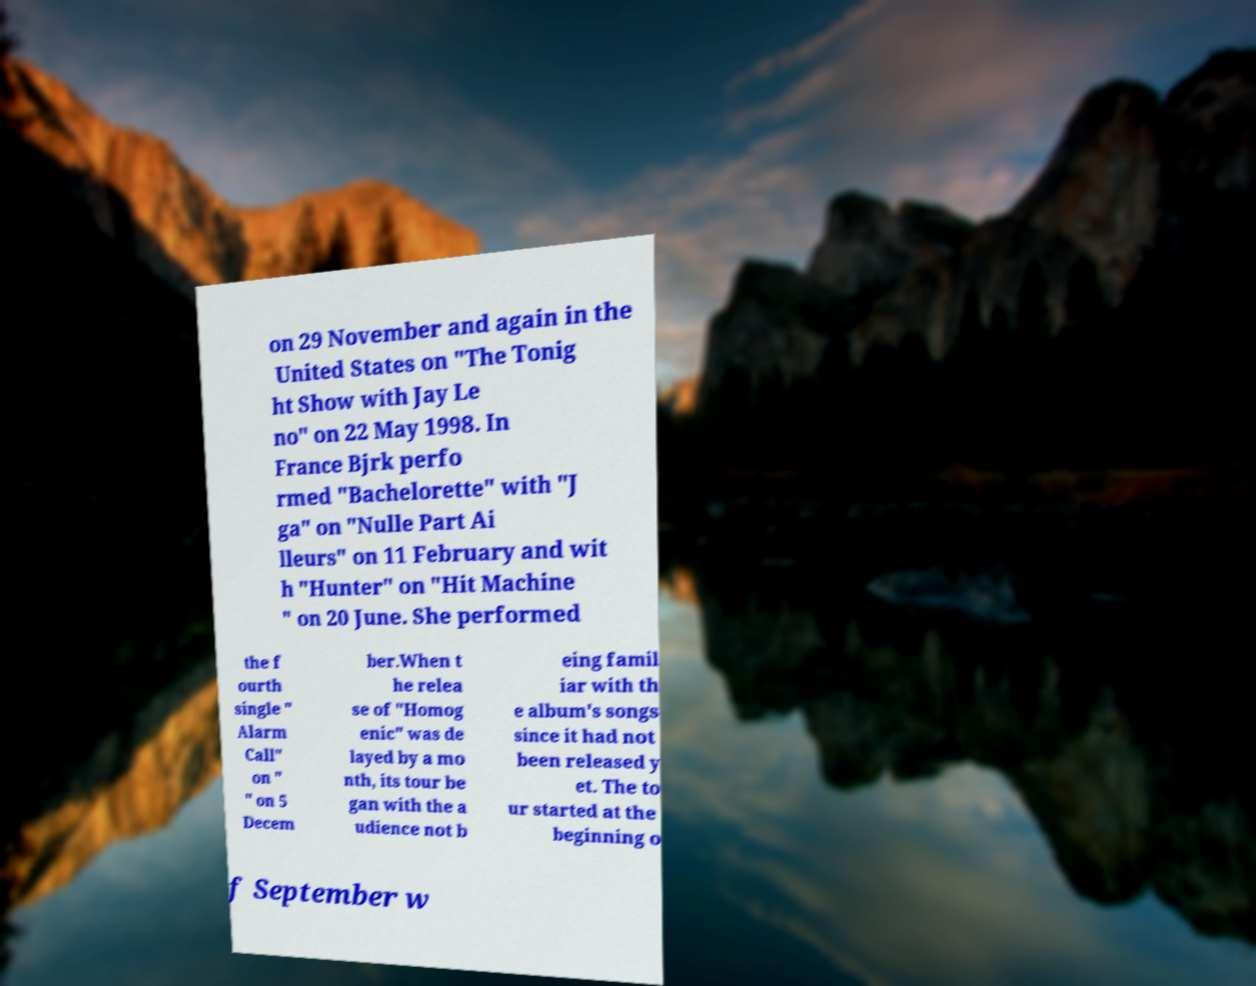Could you extract and type out the text from this image? on 29 November and again in the United States on "The Tonig ht Show with Jay Le no" on 22 May 1998. In France Bjrk perfo rmed "Bachelorette" with "J ga" on "Nulle Part Ai lleurs" on 11 February and wit h "Hunter" on "Hit Machine " on 20 June. She performed the f ourth single " Alarm Call" on " " on 5 Decem ber.When t he relea se of "Homog enic" was de layed by a mo nth, its tour be gan with the a udience not b eing famil iar with th e album's songs since it had not been released y et. The to ur started at the beginning o f September w 